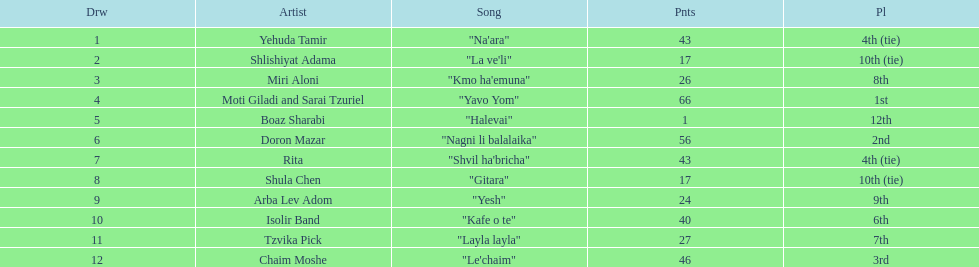What is the name of the first song listed on this chart? "Na'ara". 